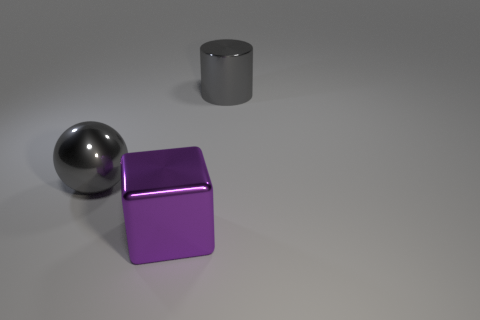Are there an equal number of large gray cylinders on the left side of the large gray metallic cylinder and objects? no 